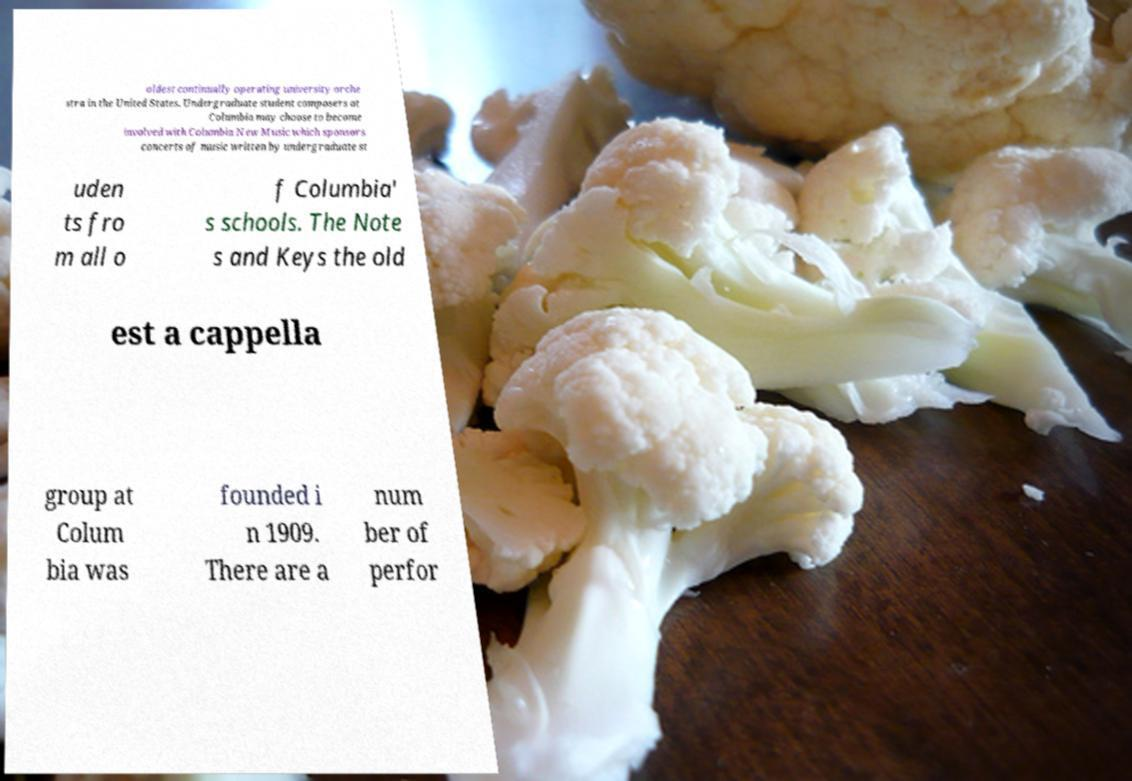Can you accurately transcribe the text from the provided image for me? oldest continually operating university orche stra in the United States. Undergraduate student composers at Columbia may choose to become involved with Columbia New Music which sponsors concerts of music written by undergraduate st uden ts fro m all o f Columbia' s schools. The Note s and Keys the old est a cappella group at Colum bia was founded i n 1909. There are a num ber of perfor 